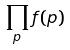Convert formula to latex. <formula><loc_0><loc_0><loc_500><loc_500>\prod _ { p } f ( p )</formula> 